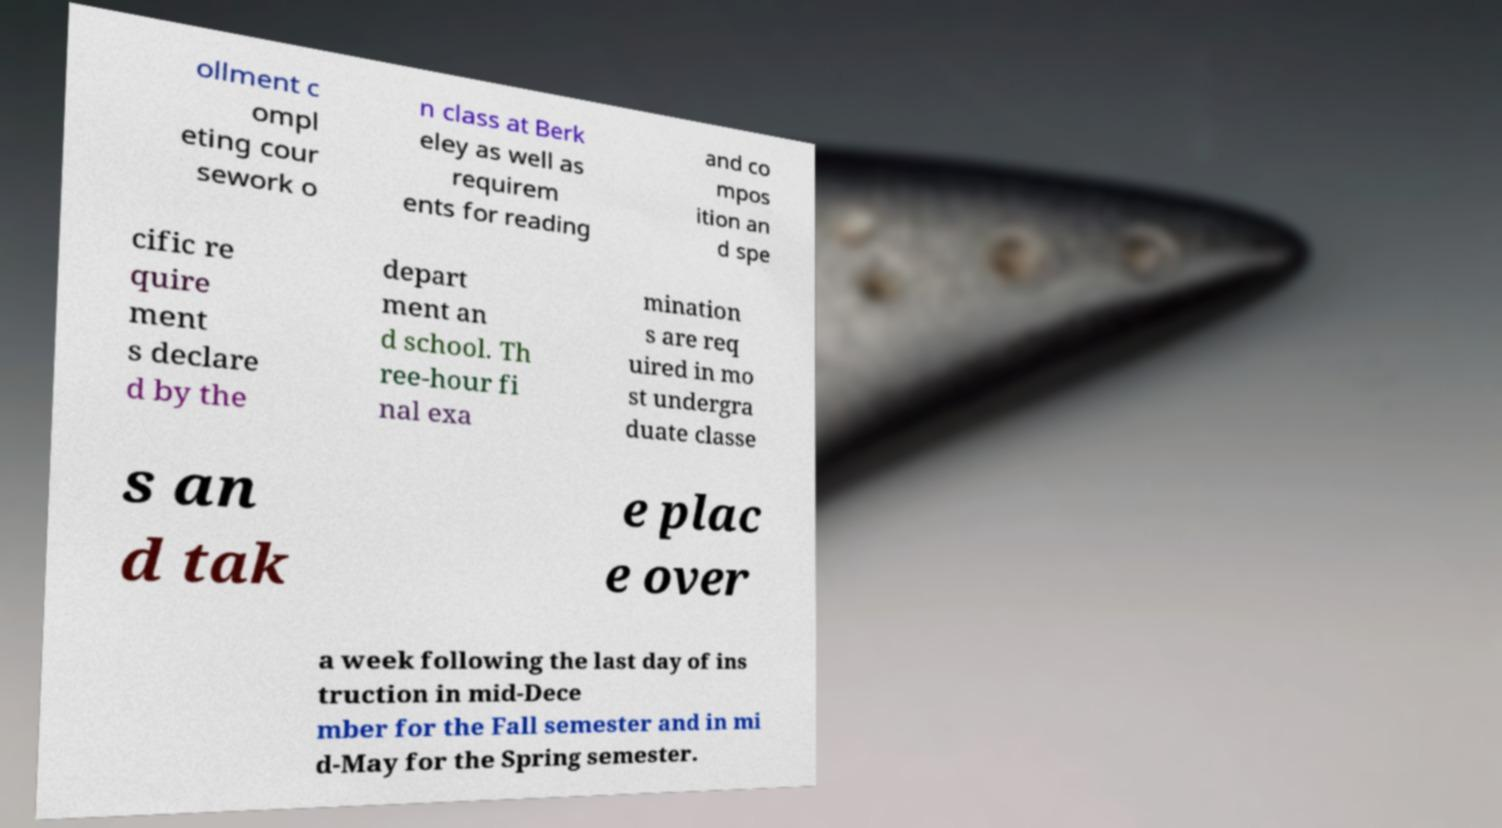Could you extract and type out the text from this image? ollment c ompl eting cour sework o n class at Berk eley as well as requirem ents for reading and co mpos ition an d spe cific re quire ment s declare d by the depart ment an d school. Th ree-hour fi nal exa mination s are req uired in mo st undergra duate classe s an d tak e plac e over a week following the last day of ins truction in mid-Dece mber for the Fall semester and in mi d-May for the Spring semester. 